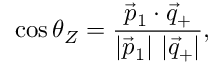Convert formula to latex. <formula><loc_0><loc_0><loc_500><loc_500>\cos \theta _ { Z } = { \frac { \vec { p } _ { 1 } \cdot \vec { q } _ { + } } { | \vec { p } _ { 1 } | \ | \vec { q } _ { + } | } } ,</formula> 